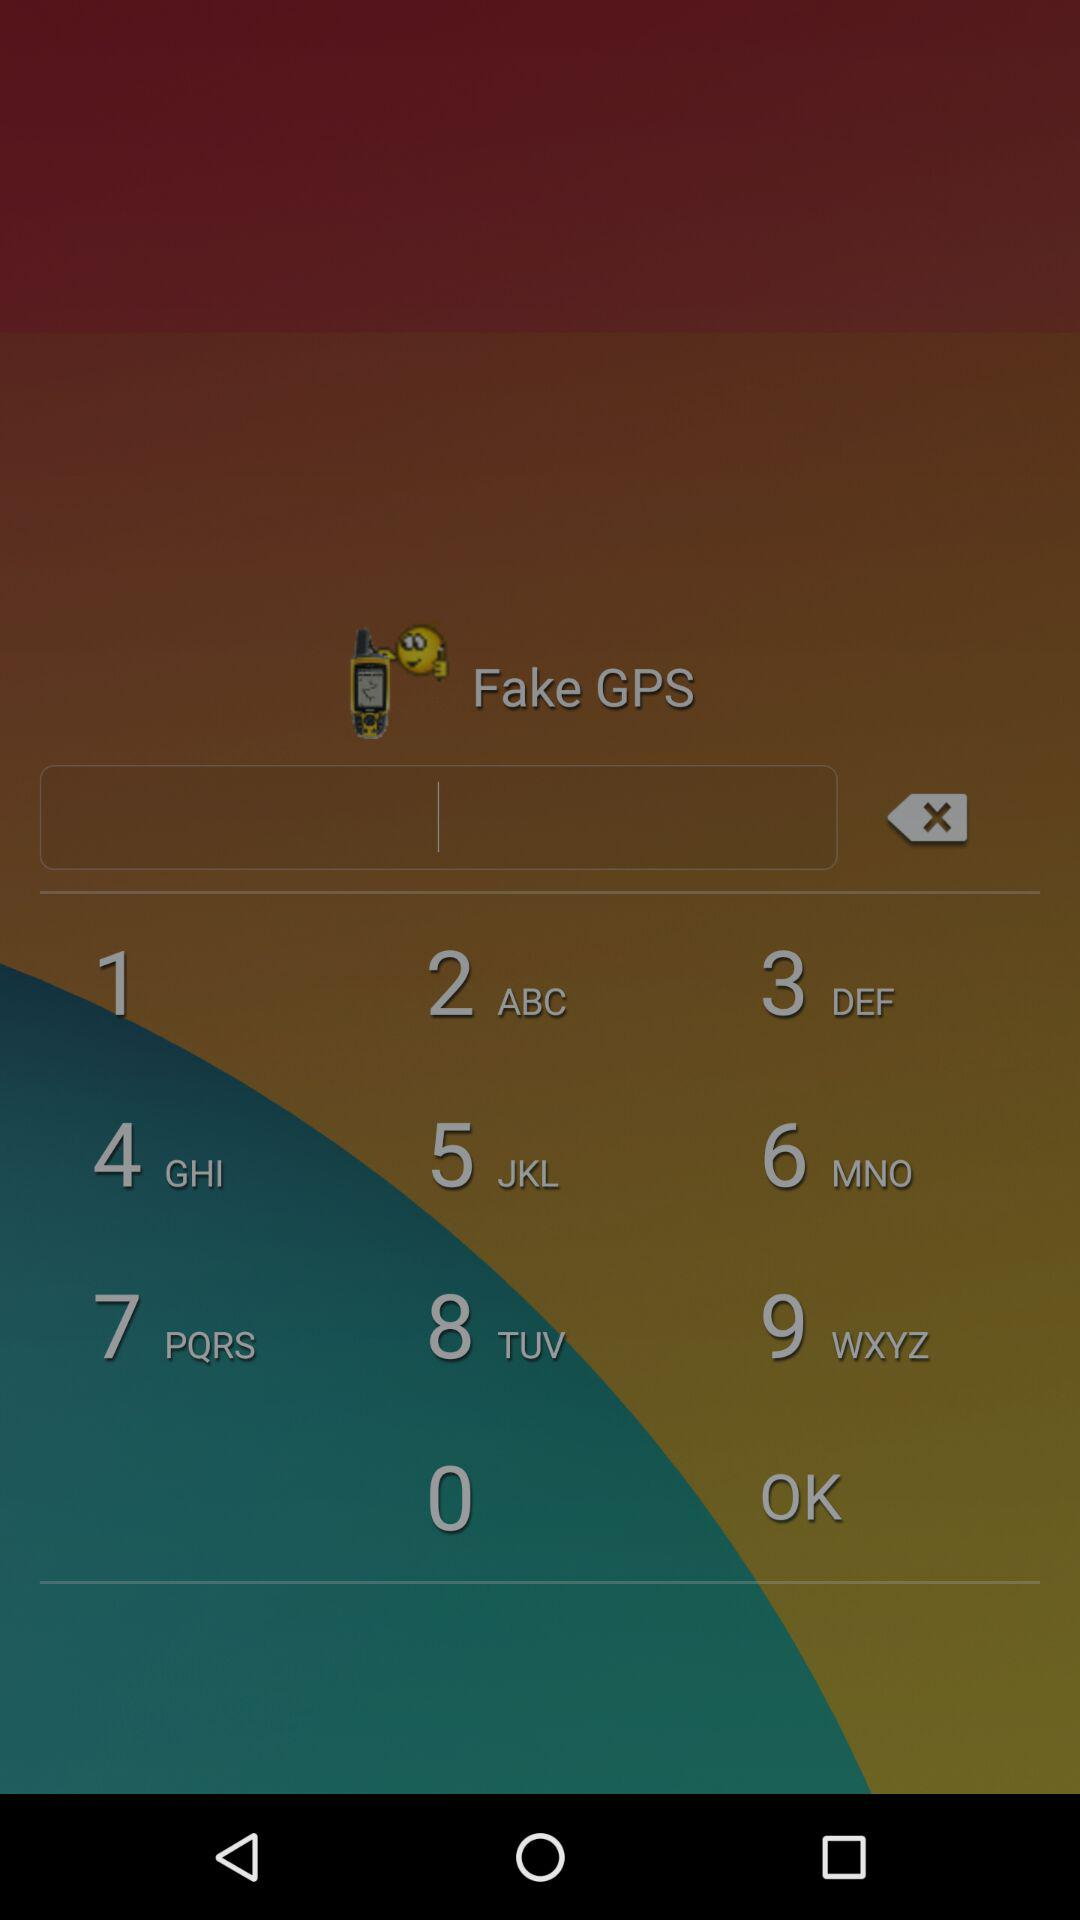What is the pincode of Sam's address? The pincode is 60007. 